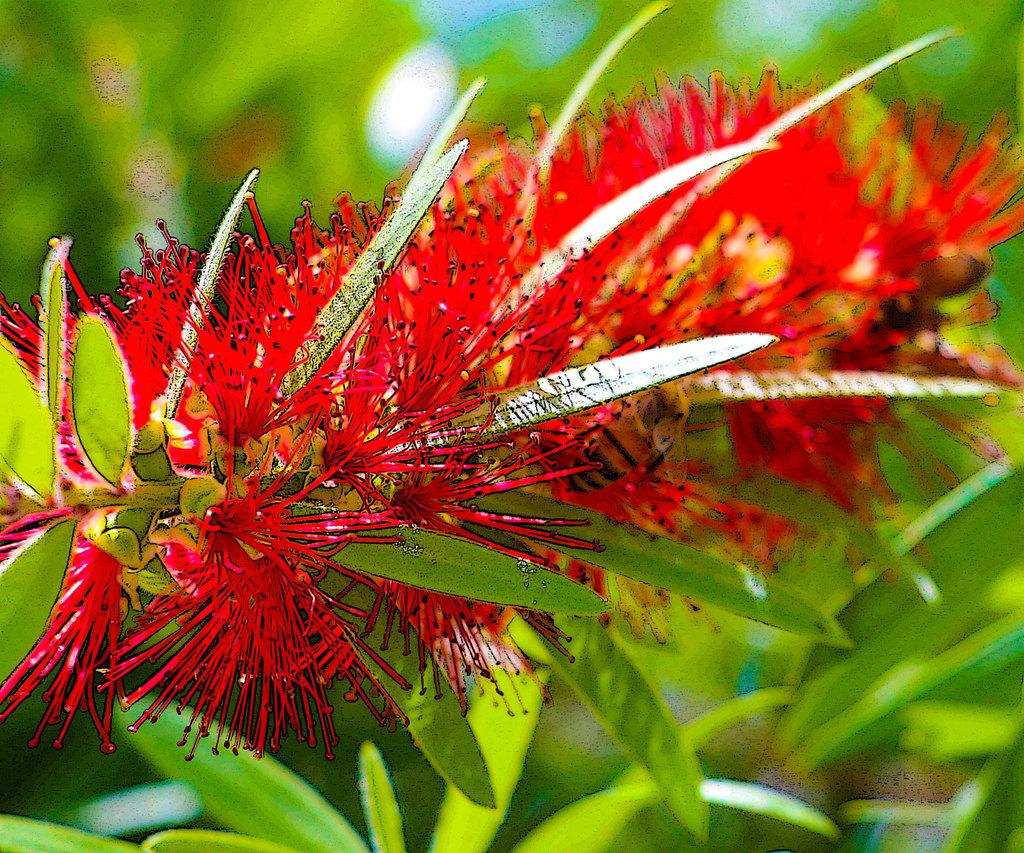What type of living organisms can be seen in the image? Plants can be seen in the image. What specific features do the plants have? The plants have leaves and flowers. What color are the flowers in the image? The flowers are red in color. What is a unique characteristic of the flowers? The flowers have thorn petals. What type of linen is being used to cover the plants in the image? There is no linen present in the image; the plants are not covered. How does the punishment system work for the flowers in the image? There is no punishment system present in the image; it is a picture of plants and flowers. 